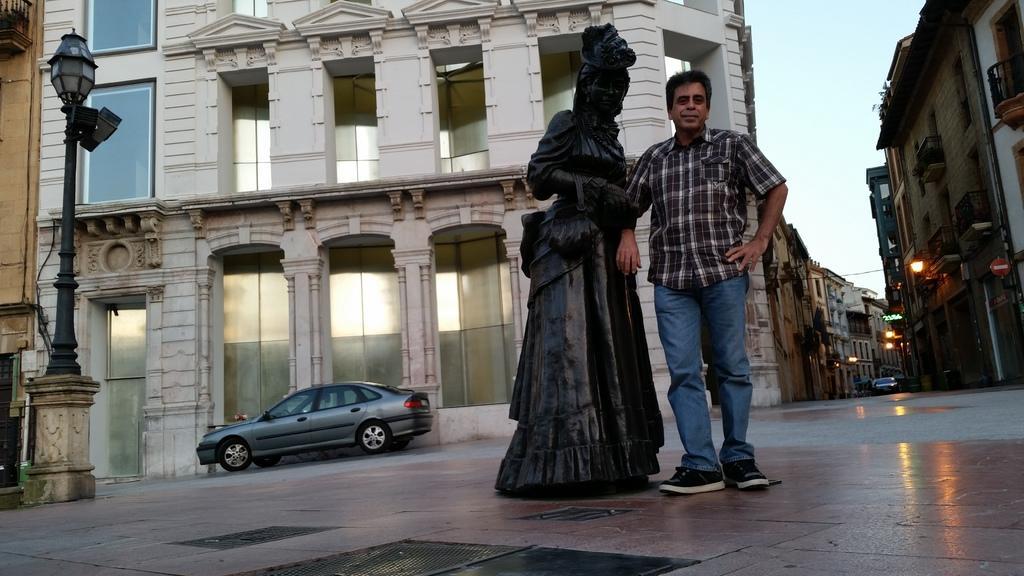Please provide a concise description of this image. In this picture I can observe a black color statue in the middle of the picture. Beside the statue there is a man standing wearing a shirt. The man is smiling. On the left side there is a car on the road. I can observe a light fixed to the black color pole on the left side. In the background there are buildings and a sky. 